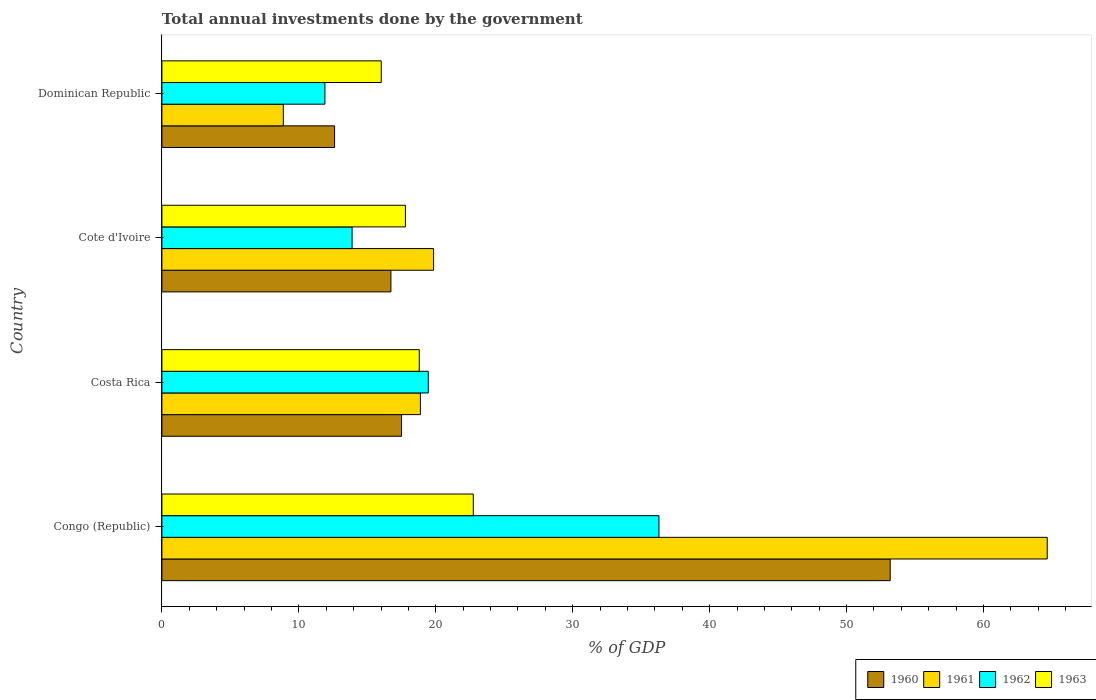How many different coloured bars are there?
Keep it short and to the point. 4. How many bars are there on the 1st tick from the top?
Your answer should be compact. 4. What is the label of the 2nd group of bars from the top?
Keep it short and to the point. Cote d'Ivoire. In how many cases, is the number of bars for a given country not equal to the number of legend labels?
Keep it short and to the point. 0. What is the total annual investments done by the government in 1961 in Congo (Republic)?
Offer a terse response. 64.65. Across all countries, what is the maximum total annual investments done by the government in 1960?
Your answer should be very brief. 53.19. Across all countries, what is the minimum total annual investments done by the government in 1962?
Provide a succinct answer. 11.9. In which country was the total annual investments done by the government in 1963 maximum?
Ensure brevity in your answer.  Congo (Republic). In which country was the total annual investments done by the government in 1960 minimum?
Keep it short and to the point. Dominican Republic. What is the total total annual investments done by the government in 1963 in the graph?
Provide a succinct answer. 75.34. What is the difference between the total annual investments done by the government in 1962 in Congo (Republic) and that in Costa Rica?
Offer a terse response. 16.85. What is the difference between the total annual investments done by the government in 1960 in Cote d'Ivoire and the total annual investments done by the government in 1963 in Costa Rica?
Your answer should be very brief. -2.07. What is the average total annual investments done by the government in 1960 per country?
Your response must be concise. 25.01. What is the difference between the total annual investments done by the government in 1963 and total annual investments done by the government in 1962 in Cote d'Ivoire?
Provide a short and direct response. 3.89. In how many countries, is the total annual investments done by the government in 1960 greater than 10 %?
Provide a short and direct response. 4. What is the ratio of the total annual investments done by the government in 1962 in Cote d'Ivoire to that in Dominican Republic?
Your answer should be very brief. 1.17. Is the difference between the total annual investments done by the government in 1963 in Costa Rica and Cote d'Ivoire greater than the difference between the total annual investments done by the government in 1962 in Costa Rica and Cote d'Ivoire?
Provide a short and direct response. No. What is the difference between the highest and the second highest total annual investments done by the government in 1963?
Provide a short and direct response. 3.95. What is the difference between the highest and the lowest total annual investments done by the government in 1961?
Provide a succinct answer. 55.79. Is the sum of the total annual investments done by the government in 1960 in Congo (Republic) and Dominican Republic greater than the maximum total annual investments done by the government in 1962 across all countries?
Make the answer very short. Yes. Is it the case that in every country, the sum of the total annual investments done by the government in 1962 and total annual investments done by the government in 1963 is greater than the sum of total annual investments done by the government in 1960 and total annual investments done by the government in 1961?
Your answer should be very brief. No. What does the 3rd bar from the top in Dominican Republic represents?
Your answer should be very brief. 1961. What does the 4th bar from the bottom in Cote d'Ivoire represents?
Offer a terse response. 1963. Is it the case that in every country, the sum of the total annual investments done by the government in 1963 and total annual investments done by the government in 1961 is greater than the total annual investments done by the government in 1962?
Provide a succinct answer. Yes. How many bars are there?
Provide a short and direct response. 16. How many countries are there in the graph?
Give a very brief answer. 4. Are the values on the major ticks of X-axis written in scientific E-notation?
Offer a terse response. No. Does the graph contain grids?
Provide a short and direct response. No. Where does the legend appear in the graph?
Offer a terse response. Bottom right. How many legend labels are there?
Offer a terse response. 4. How are the legend labels stacked?
Provide a succinct answer. Horizontal. What is the title of the graph?
Your answer should be very brief. Total annual investments done by the government. What is the label or title of the X-axis?
Your answer should be very brief. % of GDP. What is the % of GDP of 1960 in Congo (Republic)?
Your answer should be very brief. 53.19. What is the % of GDP of 1961 in Congo (Republic)?
Offer a terse response. 64.65. What is the % of GDP in 1962 in Congo (Republic)?
Ensure brevity in your answer.  36.3. What is the % of GDP in 1963 in Congo (Republic)?
Offer a terse response. 22.74. What is the % of GDP of 1960 in Costa Rica?
Keep it short and to the point. 17.5. What is the % of GDP in 1961 in Costa Rica?
Provide a short and direct response. 18.88. What is the % of GDP in 1962 in Costa Rica?
Keep it short and to the point. 19.45. What is the % of GDP in 1963 in Costa Rica?
Your answer should be very brief. 18.79. What is the % of GDP in 1960 in Cote d'Ivoire?
Ensure brevity in your answer.  16.72. What is the % of GDP of 1961 in Cote d'Ivoire?
Give a very brief answer. 19.84. What is the % of GDP in 1962 in Cote d'Ivoire?
Give a very brief answer. 13.89. What is the % of GDP of 1963 in Cote d'Ivoire?
Make the answer very short. 17.78. What is the % of GDP in 1960 in Dominican Republic?
Provide a short and direct response. 12.61. What is the % of GDP of 1961 in Dominican Republic?
Your answer should be compact. 8.87. What is the % of GDP of 1962 in Dominican Republic?
Provide a short and direct response. 11.9. What is the % of GDP in 1963 in Dominican Republic?
Offer a very short reply. 16.02. Across all countries, what is the maximum % of GDP in 1960?
Ensure brevity in your answer.  53.19. Across all countries, what is the maximum % of GDP in 1961?
Your answer should be very brief. 64.65. Across all countries, what is the maximum % of GDP of 1962?
Your response must be concise. 36.3. Across all countries, what is the maximum % of GDP in 1963?
Offer a very short reply. 22.74. Across all countries, what is the minimum % of GDP in 1960?
Offer a very short reply. 12.61. Across all countries, what is the minimum % of GDP in 1961?
Keep it short and to the point. 8.87. Across all countries, what is the minimum % of GDP in 1962?
Make the answer very short. 11.9. Across all countries, what is the minimum % of GDP in 1963?
Provide a succinct answer. 16.02. What is the total % of GDP of 1960 in the graph?
Your response must be concise. 100.02. What is the total % of GDP in 1961 in the graph?
Make the answer very short. 112.24. What is the total % of GDP in 1962 in the graph?
Your answer should be compact. 81.55. What is the total % of GDP in 1963 in the graph?
Offer a terse response. 75.34. What is the difference between the % of GDP in 1960 in Congo (Republic) and that in Costa Rica?
Give a very brief answer. 35.69. What is the difference between the % of GDP in 1961 in Congo (Republic) and that in Costa Rica?
Provide a succinct answer. 45.78. What is the difference between the % of GDP of 1962 in Congo (Republic) and that in Costa Rica?
Keep it short and to the point. 16.85. What is the difference between the % of GDP of 1963 in Congo (Republic) and that in Costa Rica?
Make the answer very short. 3.95. What is the difference between the % of GDP in 1960 in Congo (Republic) and that in Cote d'Ivoire?
Give a very brief answer. 36.46. What is the difference between the % of GDP of 1961 in Congo (Republic) and that in Cote d'Ivoire?
Ensure brevity in your answer.  44.81. What is the difference between the % of GDP in 1962 in Congo (Republic) and that in Cote d'Ivoire?
Provide a succinct answer. 22.41. What is the difference between the % of GDP in 1963 in Congo (Republic) and that in Cote d'Ivoire?
Keep it short and to the point. 4.96. What is the difference between the % of GDP in 1960 in Congo (Republic) and that in Dominican Republic?
Your answer should be very brief. 40.58. What is the difference between the % of GDP of 1961 in Congo (Republic) and that in Dominican Republic?
Your answer should be compact. 55.79. What is the difference between the % of GDP of 1962 in Congo (Republic) and that in Dominican Republic?
Give a very brief answer. 24.39. What is the difference between the % of GDP of 1963 in Congo (Republic) and that in Dominican Republic?
Offer a very short reply. 6.72. What is the difference between the % of GDP of 1960 in Costa Rica and that in Cote d'Ivoire?
Your response must be concise. 0.78. What is the difference between the % of GDP in 1961 in Costa Rica and that in Cote d'Ivoire?
Your answer should be compact. -0.96. What is the difference between the % of GDP of 1962 in Costa Rica and that in Cote d'Ivoire?
Make the answer very short. 5.56. What is the difference between the % of GDP of 1963 in Costa Rica and that in Cote d'Ivoire?
Provide a succinct answer. 1.01. What is the difference between the % of GDP of 1960 in Costa Rica and that in Dominican Republic?
Make the answer very short. 4.89. What is the difference between the % of GDP in 1961 in Costa Rica and that in Dominican Republic?
Give a very brief answer. 10.01. What is the difference between the % of GDP in 1962 in Costa Rica and that in Dominican Republic?
Your answer should be very brief. 7.55. What is the difference between the % of GDP in 1963 in Costa Rica and that in Dominican Republic?
Provide a short and direct response. 2.78. What is the difference between the % of GDP of 1960 in Cote d'Ivoire and that in Dominican Republic?
Keep it short and to the point. 4.11. What is the difference between the % of GDP of 1961 in Cote d'Ivoire and that in Dominican Republic?
Keep it short and to the point. 10.97. What is the difference between the % of GDP in 1962 in Cote d'Ivoire and that in Dominican Republic?
Provide a succinct answer. 1.99. What is the difference between the % of GDP in 1963 in Cote d'Ivoire and that in Dominican Republic?
Keep it short and to the point. 1.76. What is the difference between the % of GDP in 1960 in Congo (Republic) and the % of GDP in 1961 in Costa Rica?
Ensure brevity in your answer.  34.31. What is the difference between the % of GDP of 1960 in Congo (Republic) and the % of GDP of 1962 in Costa Rica?
Provide a short and direct response. 33.73. What is the difference between the % of GDP of 1960 in Congo (Republic) and the % of GDP of 1963 in Costa Rica?
Your answer should be very brief. 34.39. What is the difference between the % of GDP in 1961 in Congo (Republic) and the % of GDP in 1962 in Costa Rica?
Your answer should be compact. 45.2. What is the difference between the % of GDP of 1961 in Congo (Republic) and the % of GDP of 1963 in Costa Rica?
Provide a short and direct response. 45.86. What is the difference between the % of GDP in 1962 in Congo (Republic) and the % of GDP in 1963 in Costa Rica?
Ensure brevity in your answer.  17.5. What is the difference between the % of GDP in 1960 in Congo (Republic) and the % of GDP in 1961 in Cote d'Ivoire?
Offer a terse response. 33.35. What is the difference between the % of GDP in 1960 in Congo (Republic) and the % of GDP in 1962 in Cote d'Ivoire?
Your answer should be compact. 39.3. What is the difference between the % of GDP of 1960 in Congo (Republic) and the % of GDP of 1963 in Cote d'Ivoire?
Offer a very short reply. 35.4. What is the difference between the % of GDP of 1961 in Congo (Republic) and the % of GDP of 1962 in Cote d'Ivoire?
Your answer should be compact. 50.76. What is the difference between the % of GDP of 1961 in Congo (Republic) and the % of GDP of 1963 in Cote d'Ivoire?
Provide a short and direct response. 46.87. What is the difference between the % of GDP of 1962 in Congo (Republic) and the % of GDP of 1963 in Cote d'Ivoire?
Keep it short and to the point. 18.52. What is the difference between the % of GDP in 1960 in Congo (Republic) and the % of GDP in 1961 in Dominican Republic?
Offer a very short reply. 44.32. What is the difference between the % of GDP of 1960 in Congo (Republic) and the % of GDP of 1962 in Dominican Republic?
Offer a terse response. 41.28. What is the difference between the % of GDP in 1960 in Congo (Republic) and the % of GDP in 1963 in Dominican Republic?
Provide a short and direct response. 37.17. What is the difference between the % of GDP of 1961 in Congo (Republic) and the % of GDP of 1962 in Dominican Republic?
Offer a terse response. 52.75. What is the difference between the % of GDP in 1961 in Congo (Republic) and the % of GDP in 1963 in Dominican Republic?
Keep it short and to the point. 48.64. What is the difference between the % of GDP of 1962 in Congo (Republic) and the % of GDP of 1963 in Dominican Republic?
Ensure brevity in your answer.  20.28. What is the difference between the % of GDP of 1960 in Costa Rica and the % of GDP of 1961 in Cote d'Ivoire?
Give a very brief answer. -2.34. What is the difference between the % of GDP in 1960 in Costa Rica and the % of GDP in 1962 in Cote d'Ivoire?
Provide a succinct answer. 3.61. What is the difference between the % of GDP in 1960 in Costa Rica and the % of GDP in 1963 in Cote d'Ivoire?
Ensure brevity in your answer.  -0.28. What is the difference between the % of GDP of 1961 in Costa Rica and the % of GDP of 1962 in Cote d'Ivoire?
Keep it short and to the point. 4.99. What is the difference between the % of GDP in 1961 in Costa Rica and the % of GDP in 1963 in Cote d'Ivoire?
Your answer should be very brief. 1.1. What is the difference between the % of GDP of 1962 in Costa Rica and the % of GDP of 1963 in Cote d'Ivoire?
Provide a short and direct response. 1.67. What is the difference between the % of GDP in 1960 in Costa Rica and the % of GDP in 1961 in Dominican Republic?
Ensure brevity in your answer.  8.63. What is the difference between the % of GDP in 1960 in Costa Rica and the % of GDP in 1962 in Dominican Republic?
Your answer should be compact. 5.6. What is the difference between the % of GDP of 1960 in Costa Rica and the % of GDP of 1963 in Dominican Republic?
Provide a short and direct response. 1.48. What is the difference between the % of GDP in 1961 in Costa Rica and the % of GDP in 1962 in Dominican Republic?
Offer a very short reply. 6.97. What is the difference between the % of GDP of 1961 in Costa Rica and the % of GDP of 1963 in Dominican Republic?
Offer a very short reply. 2.86. What is the difference between the % of GDP of 1962 in Costa Rica and the % of GDP of 1963 in Dominican Republic?
Offer a terse response. 3.44. What is the difference between the % of GDP of 1960 in Cote d'Ivoire and the % of GDP of 1961 in Dominican Republic?
Offer a very short reply. 7.86. What is the difference between the % of GDP of 1960 in Cote d'Ivoire and the % of GDP of 1962 in Dominican Republic?
Provide a short and direct response. 4.82. What is the difference between the % of GDP of 1960 in Cote d'Ivoire and the % of GDP of 1963 in Dominican Republic?
Give a very brief answer. 0.71. What is the difference between the % of GDP in 1961 in Cote d'Ivoire and the % of GDP in 1962 in Dominican Republic?
Keep it short and to the point. 7.94. What is the difference between the % of GDP of 1961 in Cote d'Ivoire and the % of GDP of 1963 in Dominican Republic?
Ensure brevity in your answer.  3.82. What is the difference between the % of GDP in 1962 in Cote d'Ivoire and the % of GDP in 1963 in Dominican Republic?
Provide a short and direct response. -2.13. What is the average % of GDP in 1960 per country?
Make the answer very short. 25.01. What is the average % of GDP in 1961 per country?
Provide a succinct answer. 28.06. What is the average % of GDP in 1962 per country?
Make the answer very short. 20.39. What is the average % of GDP of 1963 per country?
Provide a succinct answer. 18.83. What is the difference between the % of GDP in 1960 and % of GDP in 1961 in Congo (Republic)?
Ensure brevity in your answer.  -11.47. What is the difference between the % of GDP of 1960 and % of GDP of 1962 in Congo (Republic)?
Keep it short and to the point. 16.89. What is the difference between the % of GDP in 1960 and % of GDP in 1963 in Congo (Republic)?
Keep it short and to the point. 30.45. What is the difference between the % of GDP of 1961 and % of GDP of 1962 in Congo (Republic)?
Your response must be concise. 28.36. What is the difference between the % of GDP in 1961 and % of GDP in 1963 in Congo (Republic)?
Make the answer very short. 41.91. What is the difference between the % of GDP of 1962 and % of GDP of 1963 in Congo (Republic)?
Keep it short and to the point. 13.56. What is the difference between the % of GDP in 1960 and % of GDP in 1961 in Costa Rica?
Provide a short and direct response. -1.38. What is the difference between the % of GDP in 1960 and % of GDP in 1962 in Costa Rica?
Keep it short and to the point. -1.95. What is the difference between the % of GDP in 1960 and % of GDP in 1963 in Costa Rica?
Provide a short and direct response. -1.29. What is the difference between the % of GDP of 1961 and % of GDP of 1962 in Costa Rica?
Your response must be concise. -0.58. What is the difference between the % of GDP of 1961 and % of GDP of 1963 in Costa Rica?
Ensure brevity in your answer.  0.08. What is the difference between the % of GDP in 1962 and % of GDP in 1963 in Costa Rica?
Your answer should be very brief. 0.66. What is the difference between the % of GDP in 1960 and % of GDP in 1961 in Cote d'Ivoire?
Offer a very short reply. -3.12. What is the difference between the % of GDP of 1960 and % of GDP of 1962 in Cote d'Ivoire?
Your answer should be very brief. 2.84. What is the difference between the % of GDP in 1960 and % of GDP in 1963 in Cote d'Ivoire?
Keep it short and to the point. -1.06. What is the difference between the % of GDP in 1961 and % of GDP in 1962 in Cote d'Ivoire?
Provide a succinct answer. 5.95. What is the difference between the % of GDP in 1961 and % of GDP in 1963 in Cote d'Ivoire?
Offer a very short reply. 2.06. What is the difference between the % of GDP in 1962 and % of GDP in 1963 in Cote d'Ivoire?
Make the answer very short. -3.89. What is the difference between the % of GDP of 1960 and % of GDP of 1961 in Dominican Republic?
Your answer should be compact. 3.74. What is the difference between the % of GDP of 1960 and % of GDP of 1962 in Dominican Republic?
Offer a terse response. 0.71. What is the difference between the % of GDP in 1960 and % of GDP in 1963 in Dominican Republic?
Keep it short and to the point. -3.41. What is the difference between the % of GDP of 1961 and % of GDP of 1962 in Dominican Republic?
Offer a terse response. -3.04. What is the difference between the % of GDP of 1961 and % of GDP of 1963 in Dominican Republic?
Provide a short and direct response. -7.15. What is the difference between the % of GDP of 1962 and % of GDP of 1963 in Dominican Republic?
Your answer should be compact. -4.11. What is the ratio of the % of GDP of 1960 in Congo (Republic) to that in Costa Rica?
Offer a very short reply. 3.04. What is the ratio of the % of GDP of 1961 in Congo (Republic) to that in Costa Rica?
Offer a terse response. 3.42. What is the ratio of the % of GDP in 1962 in Congo (Republic) to that in Costa Rica?
Offer a very short reply. 1.87. What is the ratio of the % of GDP in 1963 in Congo (Republic) to that in Costa Rica?
Your response must be concise. 1.21. What is the ratio of the % of GDP in 1960 in Congo (Republic) to that in Cote d'Ivoire?
Your response must be concise. 3.18. What is the ratio of the % of GDP in 1961 in Congo (Republic) to that in Cote d'Ivoire?
Your answer should be very brief. 3.26. What is the ratio of the % of GDP of 1962 in Congo (Republic) to that in Cote d'Ivoire?
Provide a short and direct response. 2.61. What is the ratio of the % of GDP in 1963 in Congo (Republic) to that in Cote d'Ivoire?
Ensure brevity in your answer.  1.28. What is the ratio of the % of GDP of 1960 in Congo (Republic) to that in Dominican Republic?
Your answer should be compact. 4.22. What is the ratio of the % of GDP of 1961 in Congo (Republic) to that in Dominican Republic?
Provide a short and direct response. 7.29. What is the ratio of the % of GDP in 1962 in Congo (Republic) to that in Dominican Republic?
Make the answer very short. 3.05. What is the ratio of the % of GDP in 1963 in Congo (Republic) to that in Dominican Republic?
Give a very brief answer. 1.42. What is the ratio of the % of GDP in 1960 in Costa Rica to that in Cote d'Ivoire?
Provide a short and direct response. 1.05. What is the ratio of the % of GDP of 1961 in Costa Rica to that in Cote d'Ivoire?
Offer a very short reply. 0.95. What is the ratio of the % of GDP in 1962 in Costa Rica to that in Cote d'Ivoire?
Give a very brief answer. 1.4. What is the ratio of the % of GDP in 1963 in Costa Rica to that in Cote d'Ivoire?
Keep it short and to the point. 1.06. What is the ratio of the % of GDP of 1960 in Costa Rica to that in Dominican Republic?
Provide a succinct answer. 1.39. What is the ratio of the % of GDP of 1961 in Costa Rica to that in Dominican Republic?
Ensure brevity in your answer.  2.13. What is the ratio of the % of GDP of 1962 in Costa Rica to that in Dominican Republic?
Give a very brief answer. 1.63. What is the ratio of the % of GDP of 1963 in Costa Rica to that in Dominican Republic?
Keep it short and to the point. 1.17. What is the ratio of the % of GDP of 1960 in Cote d'Ivoire to that in Dominican Republic?
Keep it short and to the point. 1.33. What is the ratio of the % of GDP in 1961 in Cote d'Ivoire to that in Dominican Republic?
Provide a short and direct response. 2.24. What is the ratio of the % of GDP of 1962 in Cote d'Ivoire to that in Dominican Republic?
Provide a succinct answer. 1.17. What is the ratio of the % of GDP in 1963 in Cote d'Ivoire to that in Dominican Republic?
Make the answer very short. 1.11. What is the difference between the highest and the second highest % of GDP in 1960?
Keep it short and to the point. 35.69. What is the difference between the highest and the second highest % of GDP of 1961?
Your answer should be very brief. 44.81. What is the difference between the highest and the second highest % of GDP in 1962?
Ensure brevity in your answer.  16.85. What is the difference between the highest and the second highest % of GDP in 1963?
Keep it short and to the point. 3.95. What is the difference between the highest and the lowest % of GDP of 1960?
Your response must be concise. 40.58. What is the difference between the highest and the lowest % of GDP in 1961?
Provide a short and direct response. 55.79. What is the difference between the highest and the lowest % of GDP of 1962?
Your response must be concise. 24.39. What is the difference between the highest and the lowest % of GDP of 1963?
Your response must be concise. 6.72. 